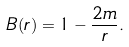Convert formula to latex. <formula><loc_0><loc_0><loc_500><loc_500>B ( r ) = 1 - \frac { 2 m } { r } .</formula> 